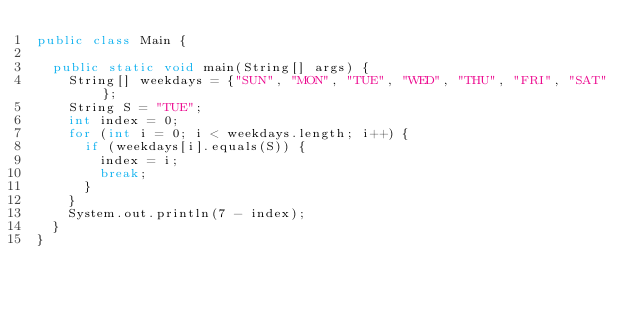Convert code to text. <code><loc_0><loc_0><loc_500><loc_500><_Java_>public class Main {
	
	public static void main(String[] args) {
		String[] weekdays = {"SUN", "MON", "TUE", "WED", "THU", "FRI", "SAT"};
		String S = "TUE";
		int index = 0;
		for (int i = 0; i < weekdays.length; i++) {
			if (weekdays[i].equals(S)) {
				index = i;
				break;
			}
		}
		System.out.println(7 - index);
	}
}</code> 